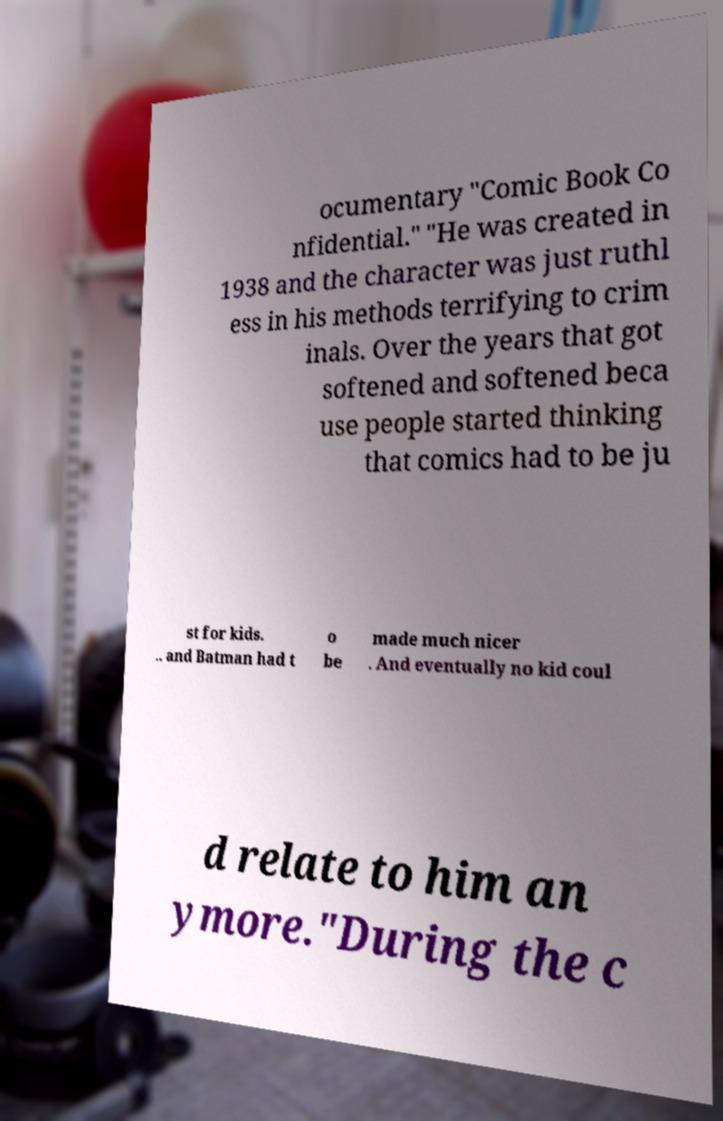Please identify and transcribe the text found in this image. ocumentary "Comic Book Co nfidential." "He was created in 1938 and the character was just ruthl ess in his methods terrifying to crim inals. Over the years that got softened and softened beca use people started thinking that comics had to be ju st for kids. .. and Batman had t o be made much nicer . And eventually no kid coul d relate to him an ymore."During the c 